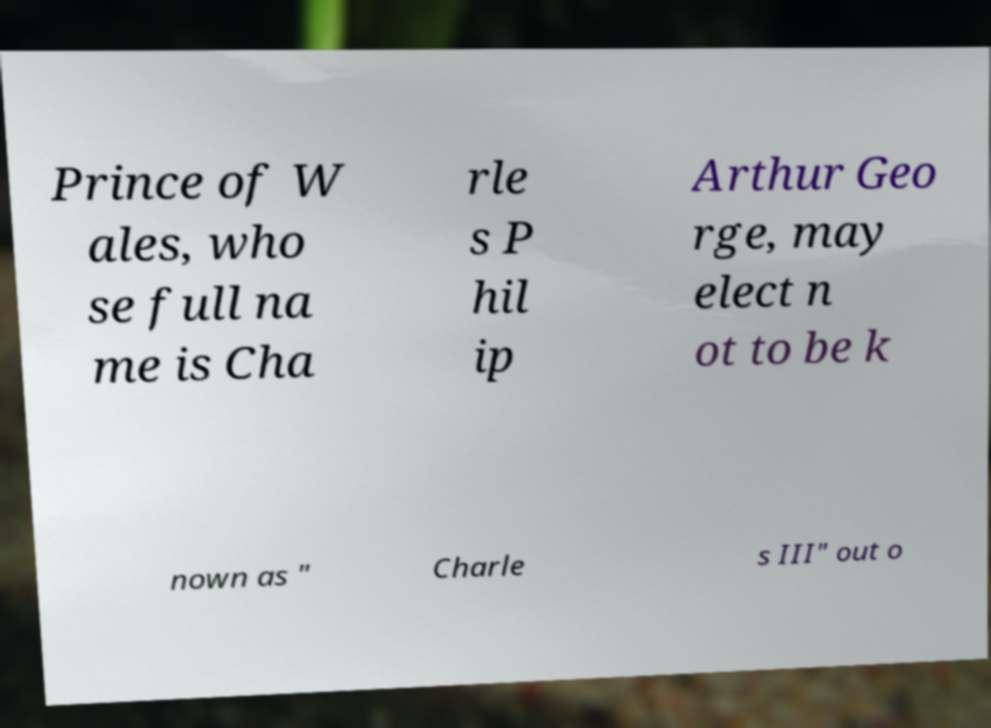Could you extract and type out the text from this image? Prince of W ales, who se full na me is Cha rle s P hil ip Arthur Geo rge, may elect n ot to be k nown as " Charle s III" out o 